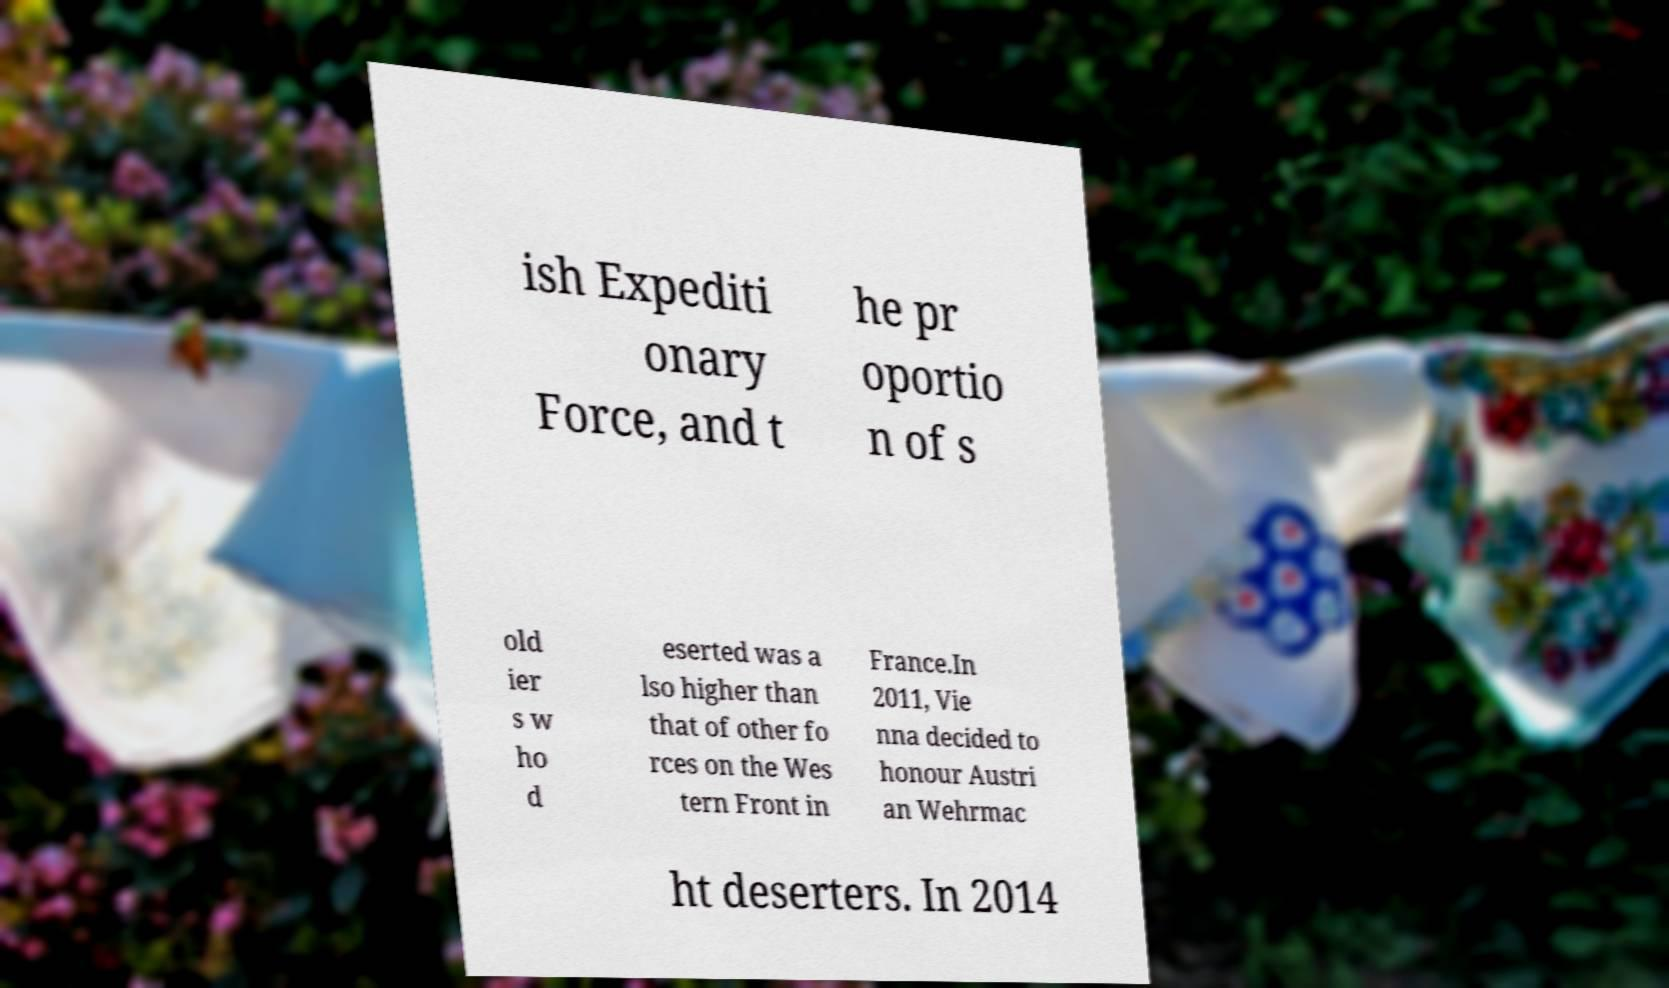Could you extract and type out the text from this image? ish Expediti onary Force, and t he pr oportio n of s old ier s w ho d eserted was a lso higher than that of other fo rces on the Wes tern Front in France.In 2011, Vie nna decided to honour Austri an Wehrmac ht deserters. In 2014 